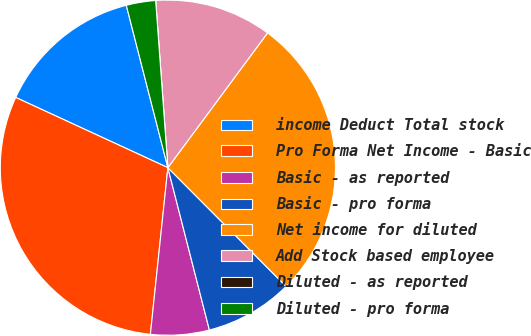Convert chart. <chart><loc_0><loc_0><loc_500><loc_500><pie_chart><fcel>income Deduct Total stock<fcel>Pro Forma Net Income - Basic<fcel>Basic - as reported<fcel>Basic - pro forma<fcel>Net income for diluted<fcel>Add Stock based employee<fcel>Diluted - as reported<fcel>Diluted - pro forma<nl><fcel>14.13%<fcel>30.22%<fcel>5.65%<fcel>8.48%<fcel>27.4%<fcel>11.3%<fcel>0.0%<fcel>2.83%<nl></chart> 